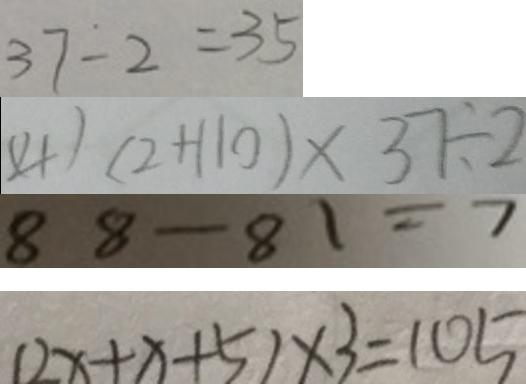Convert formula to latex. <formula><loc_0><loc_0><loc_500><loc_500>3 7 - 2 = 3 5 
 ( 4 ) ( 2 + 1 1 0 ) \times 3 7 \div 2 
 8 8 - 8 1 = 7 
 ( 2 x + x + 5 ) \times 3 = 1 0 5</formula> 